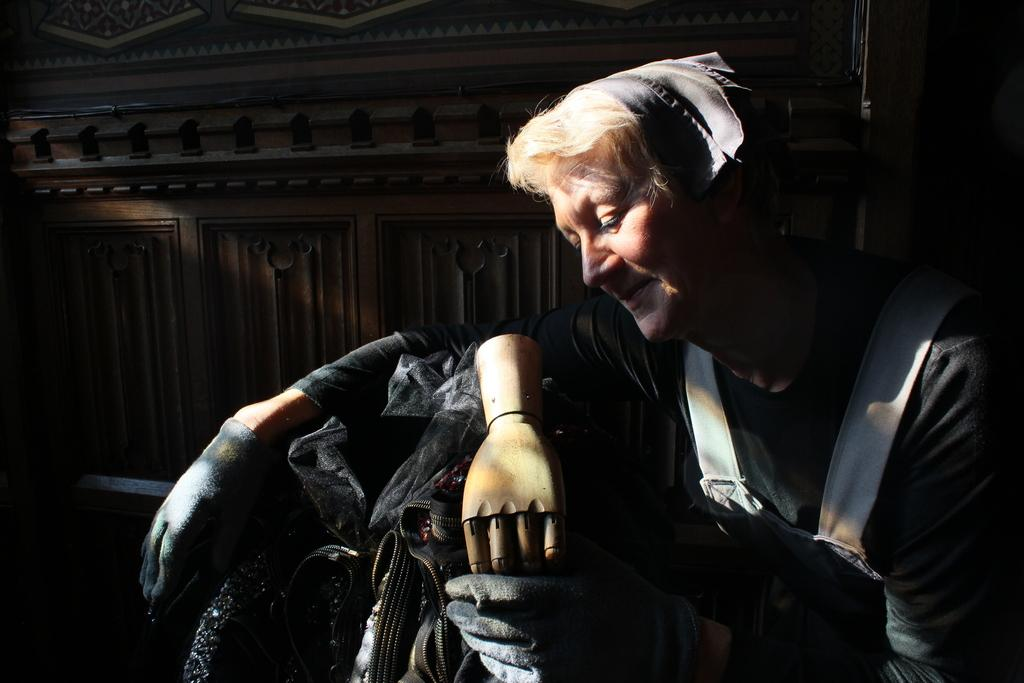Who is present in the image? There is a woman in the image. What is the woman holding in her hand? The woman is holding a plastic hand. What else is the woman holding? The woman is also holding a handbag and a cloth. What can be seen behind the woman? There is a wall visible behind the woman. Is there a man fighting with the woman in the image? No, there is no man present in the image, and there is no indication of a fight. 